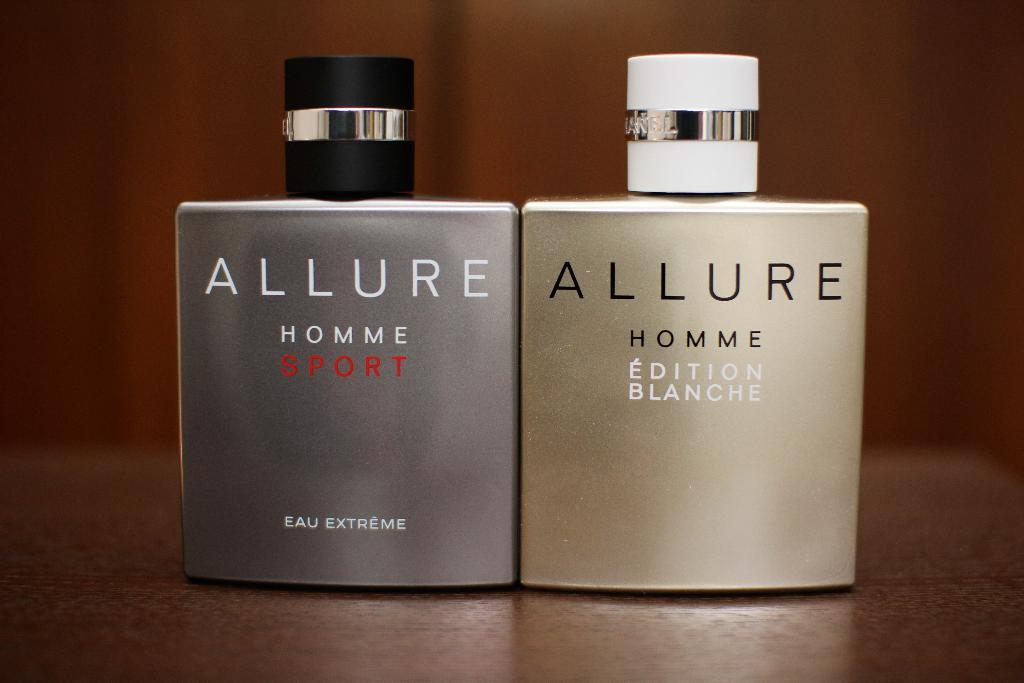<image>
Share a concise interpretation of the image provided. Two versions of cologne made for men by Allure sit on a hard wooden surface. 